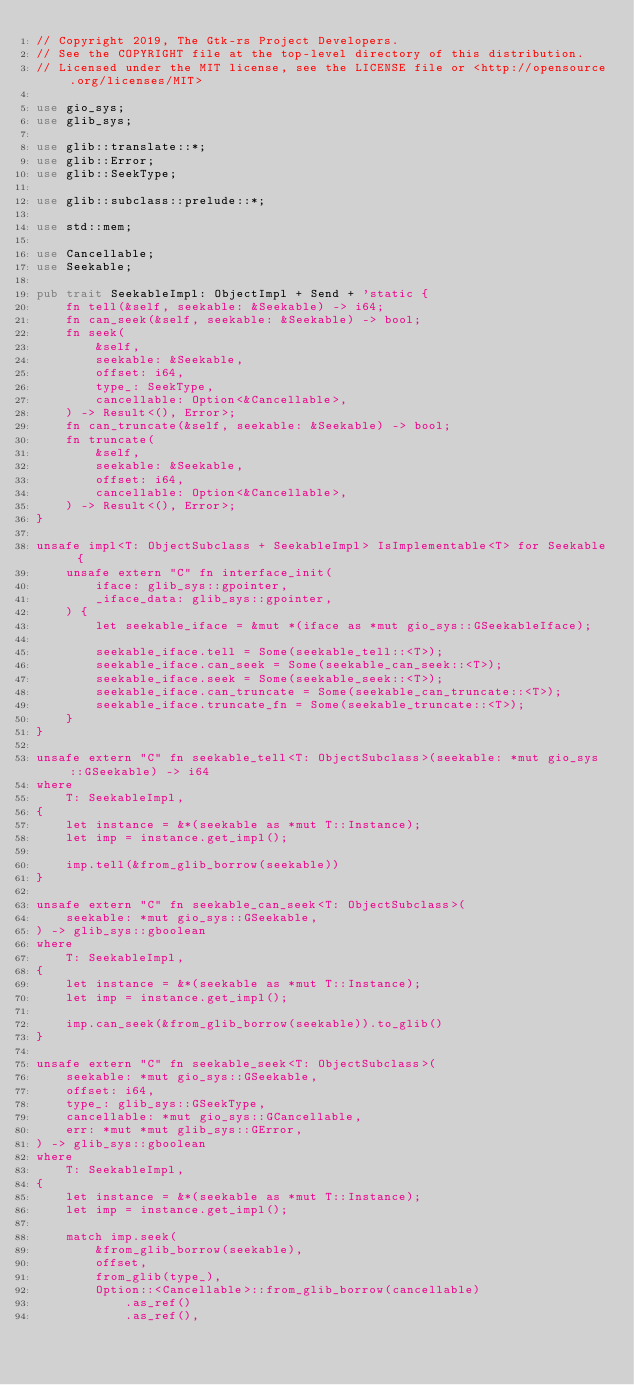Convert code to text. <code><loc_0><loc_0><loc_500><loc_500><_Rust_>// Copyright 2019, The Gtk-rs Project Developers.
// See the COPYRIGHT file at the top-level directory of this distribution.
// Licensed under the MIT license, see the LICENSE file or <http://opensource.org/licenses/MIT>

use gio_sys;
use glib_sys;

use glib::translate::*;
use glib::Error;
use glib::SeekType;

use glib::subclass::prelude::*;

use std::mem;

use Cancellable;
use Seekable;

pub trait SeekableImpl: ObjectImpl + Send + 'static {
    fn tell(&self, seekable: &Seekable) -> i64;
    fn can_seek(&self, seekable: &Seekable) -> bool;
    fn seek(
        &self,
        seekable: &Seekable,
        offset: i64,
        type_: SeekType,
        cancellable: Option<&Cancellable>,
    ) -> Result<(), Error>;
    fn can_truncate(&self, seekable: &Seekable) -> bool;
    fn truncate(
        &self,
        seekable: &Seekable,
        offset: i64,
        cancellable: Option<&Cancellable>,
    ) -> Result<(), Error>;
}

unsafe impl<T: ObjectSubclass + SeekableImpl> IsImplementable<T> for Seekable {
    unsafe extern "C" fn interface_init(
        iface: glib_sys::gpointer,
        _iface_data: glib_sys::gpointer,
    ) {
        let seekable_iface = &mut *(iface as *mut gio_sys::GSeekableIface);

        seekable_iface.tell = Some(seekable_tell::<T>);
        seekable_iface.can_seek = Some(seekable_can_seek::<T>);
        seekable_iface.seek = Some(seekable_seek::<T>);
        seekable_iface.can_truncate = Some(seekable_can_truncate::<T>);
        seekable_iface.truncate_fn = Some(seekable_truncate::<T>);
    }
}

unsafe extern "C" fn seekable_tell<T: ObjectSubclass>(seekable: *mut gio_sys::GSeekable) -> i64
where
    T: SeekableImpl,
{
    let instance = &*(seekable as *mut T::Instance);
    let imp = instance.get_impl();

    imp.tell(&from_glib_borrow(seekable))
}

unsafe extern "C" fn seekable_can_seek<T: ObjectSubclass>(
    seekable: *mut gio_sys::GSeekable,
) -> glib_sys::gboolean
where
    T: SeekableImpl,
{
    let instance = &*(seekable as *mut T::Instance);
    let imp = instance.get_impl();

    imp.can_seek(&from_glib_borrow(seekable)).to_glib()
}

unsafe extern "C" fn seekable_seek<T: ObjectSubclass>(
    seekable: *mut gio_sys::GSeekable,
    offset: i64,
    type_: glib_sys::GSeekType,
    cancellable: *mut gio_sys::GCancellable,
    err: *mut *mut glib_sys::GError,
) -> glib_sys::gboolean
where
    T: SeekableImpl,
{
    let instance = &*(seekable as *mut T::Instance);
    let imp = instance.get_impl();

    match imp.seek(
        &from_glib_borrow(seekable),
        offset,
        from_glib(type_),
        Option::<Cancellable>::from_glib_borrow(cancellable)
            .as_ref()
            .as_ref(),</code> 